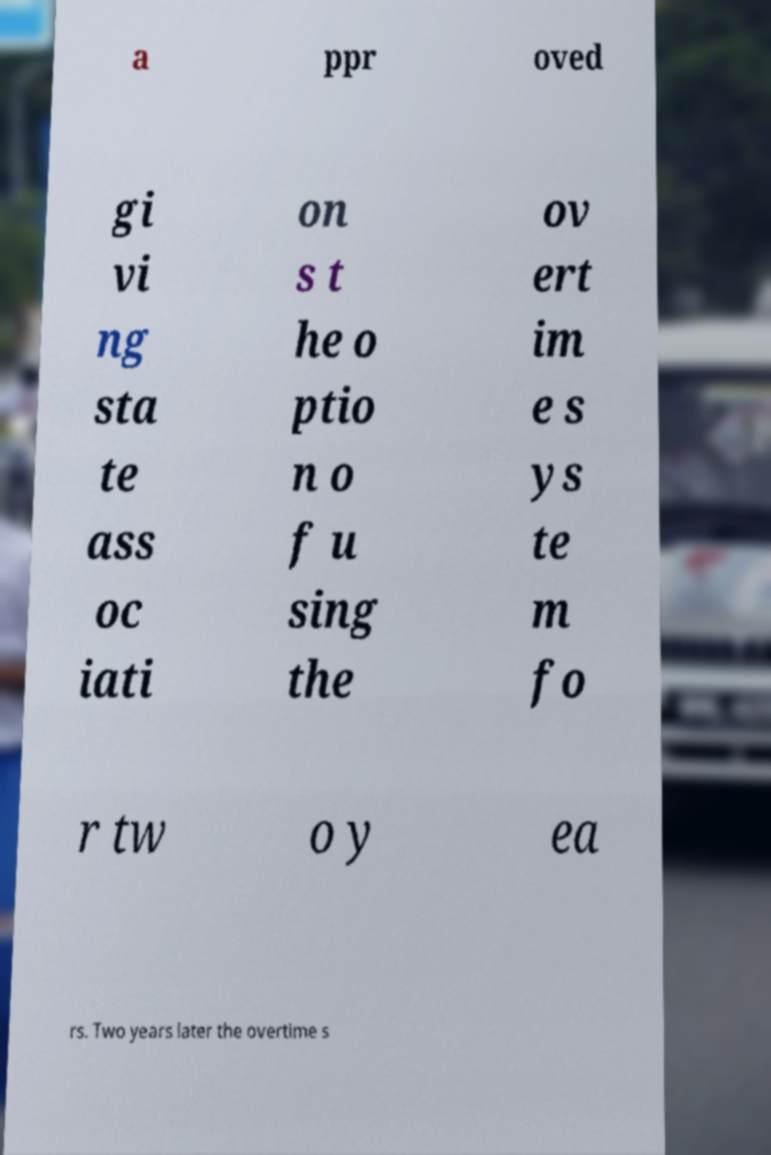Can you accurately transcribe the text from the provided image for me? a ppr oved gi vi ng sta te ass oc iati on s t he o ptio n o f u sing the ov ert im e s ys te m fo r tw o y ea rs. Two years later the overtime s 